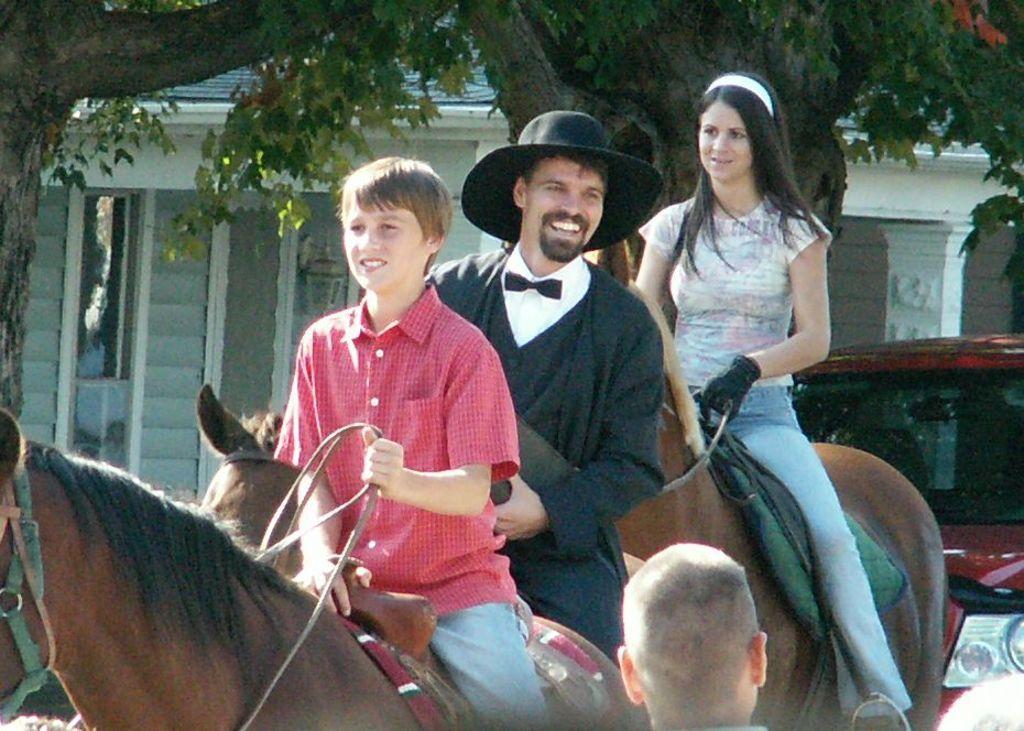In one or two sentences, can you explain what this image depicts? In this image, There are some people sitting on the horses and there is a man standing and he is looking at the horse, In the background there is a red color car and there are some green color trees. 